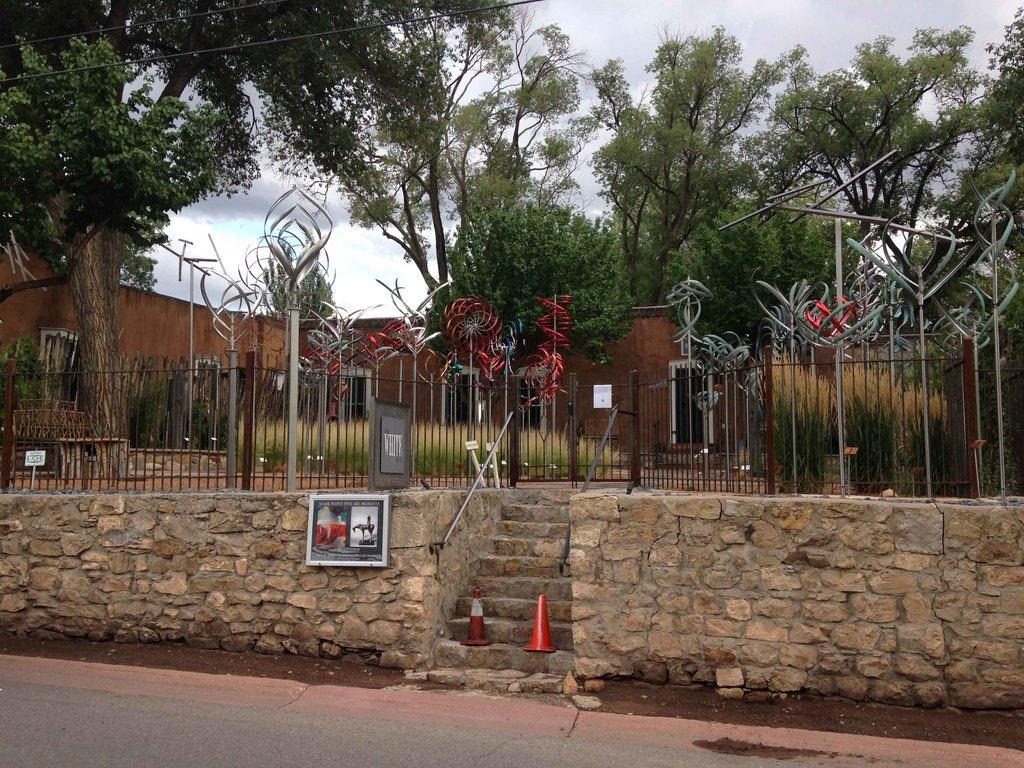How would you summarize this image in a sentence or two? This image is taken outdoors. At the bottom of the image there is a road. At the top of the image there is the sky. In the background there is a house and there are many trees and plants on the ground. There is a railing and there are many poles. There is a brick wall and a few stairs. There are two safety cones on the stairs and there is a board with an image and there is a text on it. 